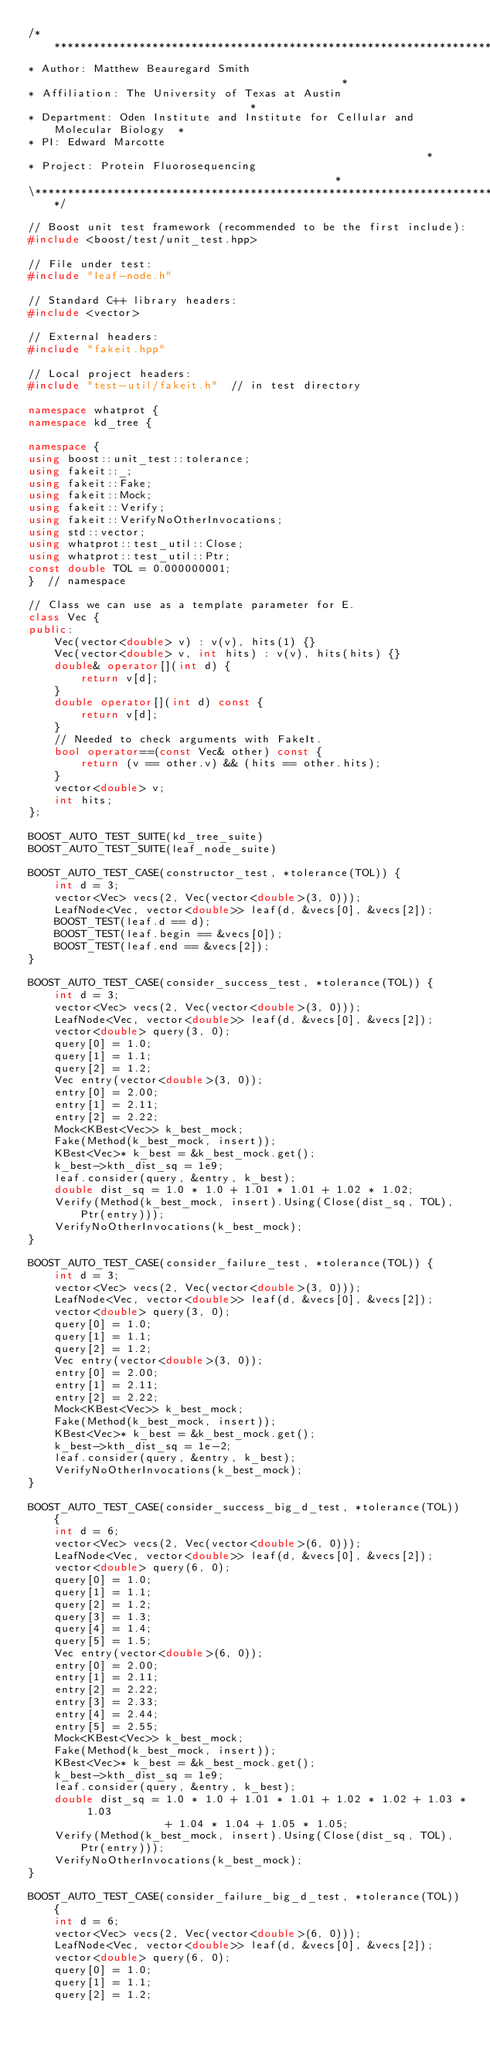Convert code to text. <code><loc_0><loc_0><loc_500><loc_500><_C++_>/******************************************************************************\
* Author: Matthew Beauregard Smith                                             *
* Affiliation: The University of Texas at Austin                               *
* Department: Oden Institute and Institute for Cellular and Molecular Biology  *
* PI: Edward Marcotte                                                          *
* Project: Protein Fluorosequencing                                            *
\******************************************************************************/

// Boost unit test framework (recommended to be the first include):
#include <boost/test/unit_test.hpp>

// File under test:
#include "leaf-node.h"

// Standard C++ library headers:
#include <vector>

// External headers:
#include "fakeit.hpp"

// Local project headers:
#include "test-util/fakeit.h"  // in test directory

namespace whatprot {
namespace kd_tree {

namespace {
using boost::unit_test::tolerance;
using fakeit::_;
using fakeit::Fake;
using fakeit::Mock;
using fakeit::Verify;
using fakeit::VerifyNoOtherInvocations;
using std::vector;
using whatprot::test_util::Close;
using whatprot::test_util::Ptr;
const double TOL = 0.000000001;
}  // namespace

// Class we can use as a template parameter for E.
class Vec {
public:
    Vec(vector<double> v) : v(v), hits(1) {}
    Vec(vector<double> v, int hits) : v(v), hits(hits) {}
    double& operator[](int d) {
        return v[d];
    }
    double operator[](int d) const {
        return v[d];
    }
    // Needed to check arguments with FakeIt.
    bool operator==(const Vec& other) const {
        return (v == other.v) && (hits == other.hits);
    }
    vector<double> v;
    int hits;
};

BOOST_AUTO_TEST_SUITE(kd_tree_suite)
BOOST_AUTO_TEST_SUITE(leaf_node_suite)

BOOST_AUTO_TEST_CASE(constructor_test, *tolerance(TOL)) {
    int d = 3;
    vector<Vec> vecs(2, Vec(vector<double>(3, 0)));
    LeafNode<Vec, vector<double>> leaf(d, &vecs[0], &vecs[2]);
    BOOST_TEST(leaf.d == d);
    BOOST_TEST(leaf.begin == &vecs[0]);
    BOOST_TEST(leaf.end == &vecs[2]);
}

BOOST_AUTO_TEST_CASE(consider_success_test, *tolerance(TOL)) {
    int d = 3;
    vector<Vec> vecs(2, Vec(vector<double>(3, 0)));
    LeafNode<Vec, vector<double>> leaf(d, &vecs[0], &vecs[2]);
    vector<double> query(3, 0);
    query[0] = 1.0;
    query[1] = 1.1;
    query[2] = 1.2;
    Vec entry(vector<double>(3, 0));
    entry[0] = 2.00;
    entry[1] = 2.11;
    entry[2] = 2.22;
    Mock<KBest<Vec>> k_best_mock;
    Fake(Method(k_best_mock, insert));
    KBest<Vec>* k_best = &k_best_mock.get();
    k_best->kth_dist_sq = 1e9;
    leaf.consider(query, &entry, k_best);
    double dist_sq = 1.0 * 1.0 + 1.01 * 1.01 + 1.02 * 1.02;
    Verify(Method(k_best_mock, insert).Using(Close(dist_sq, TOL), Ptr(entry)));
    VerifyNoOtherInvocations(k_best_mock);
}

BOOST_AUTO_TEST_CASE(consider_failure_test, *tolerance(TOL)) {
    int d = 3;
    vector<Vec> vecs(2, Vec(vector<double>(3, 0)));
    LeafNode<Vec, vector<double>> leaf(d, &vecs[0], &vecs[2]);
    vector<double> query(3, 0);
    query[0] = 1.0;
    query[1] = 1.1;
    query[2] = 1.2;
    Vec entry(vector<double>(3, 0));
    entry[0] = 2.00;
    entry[1] = 2.11;
    entry[2] = 2.22;
    Mock<KBest<Vec>> k_best_mock;
    Fake(Method(k_best_mock, insert));
    KBest<Vec>* k_best = &k_best_mock.get();
    k_best->kth_dist_sq = 1e-2;
    leaf.consider(query, &entry, k_best);
    VerifyNoOtherInvocations(k_best_mock);
}

BOOST_AUTO_TEST_CASE(consider_success_big_d_test, *tolerance(TOL)) {
    int d = 6;
    vector<Vec> vecs(2, Vec(vector<double>(6, 0)));
    LeafNode<Vec, vector<double>> leaf(d, &vecs[0], &vecs[2]);
    vector<double> query(6, 0);
    query[0] = 1.0;
    query[1] = 1.1;
    query[2] = 1.2;
    query[3] = 1.3;
    query[4] = 1.4;
    query[5] = 1.5;
    Vec entry(vector<double>(6, 0));
    entry[0] = 2.00;
    entry[1] = 2.11;
    entry[2] = 2.22;
    entry[3] = 2.33;
    entry[4] = 2.44;
    entry[5] = 2.55;
    Mock<KBest<Vec>> k_best_mock;
    Fake(Method(k_best_mock, insert));
    KBest<Vec>* k_best = &k_best_mock.get();
    k_best->kth_dist_sq = 1e9;
    leaf.consider(query, &entry, k_best);
    double dist_sq = 1.0 * 1.0 + 1.01 * 1.01 + 1.02 * 1.02 + 1.03 * 1.03
                     + 1.04 * 1.04 + 1.05 * 1.05;
    Verify(Method(k_best_mock, insert).Using(Close(dist_sq, TOL), Ptr(entry)));
    VerifyNoOtherInvocations(k_best_mock);
}

BOOST_AUTO_TEST_CASE(consider_failure_big_d_test, *tolerance(TOL)) {
    int d = 6;
    vector<Vec> vecs(2, Vec(vector<double>(6, 0)));
    LeafNode<Vec, vector<double>> leaf(d, &vecs[0], &vecs[2]);
    vector<double> query(6, 0);
    query[0] = 1.0;
    query[1] = 1.1;
    query[2] = 1.2;</code> 